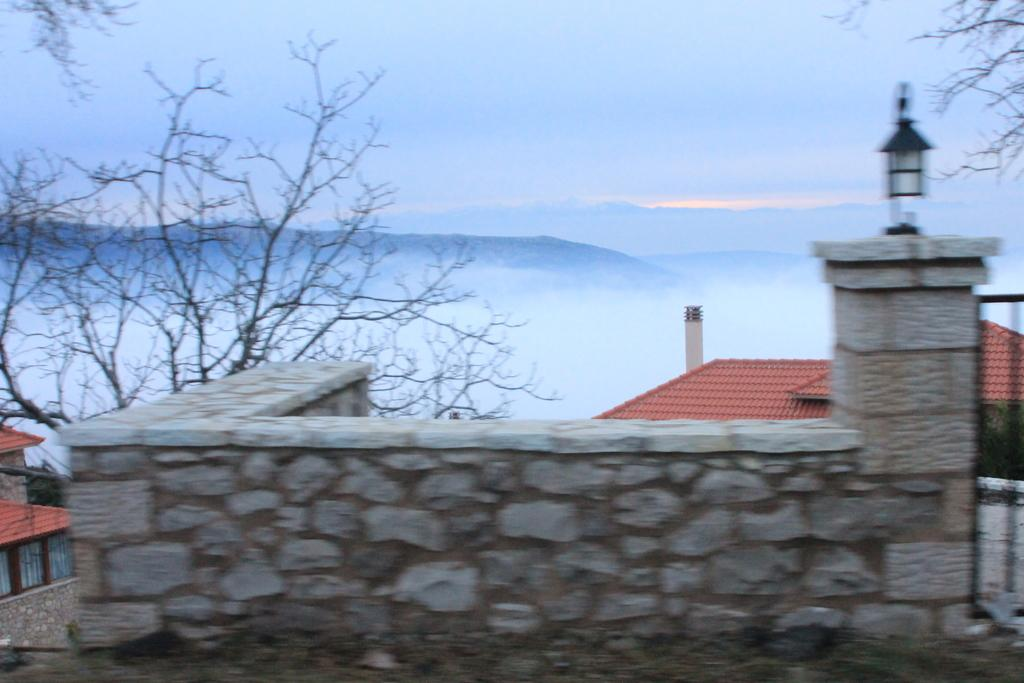What is present in the foreground of the image? There is a wall in the image. What can be seen in the distance behind the wall? There are houses, trees, a mountain, and the sky visible in the background of the image. How many different types of natural elements are present in the background? There are three different types of natural elements in the background: trees, a mountain, and the sky. What hand gesture is being made by the mountain in the image? There is no hand gesture made by the mountain in the image, as mountains do not have hands. 